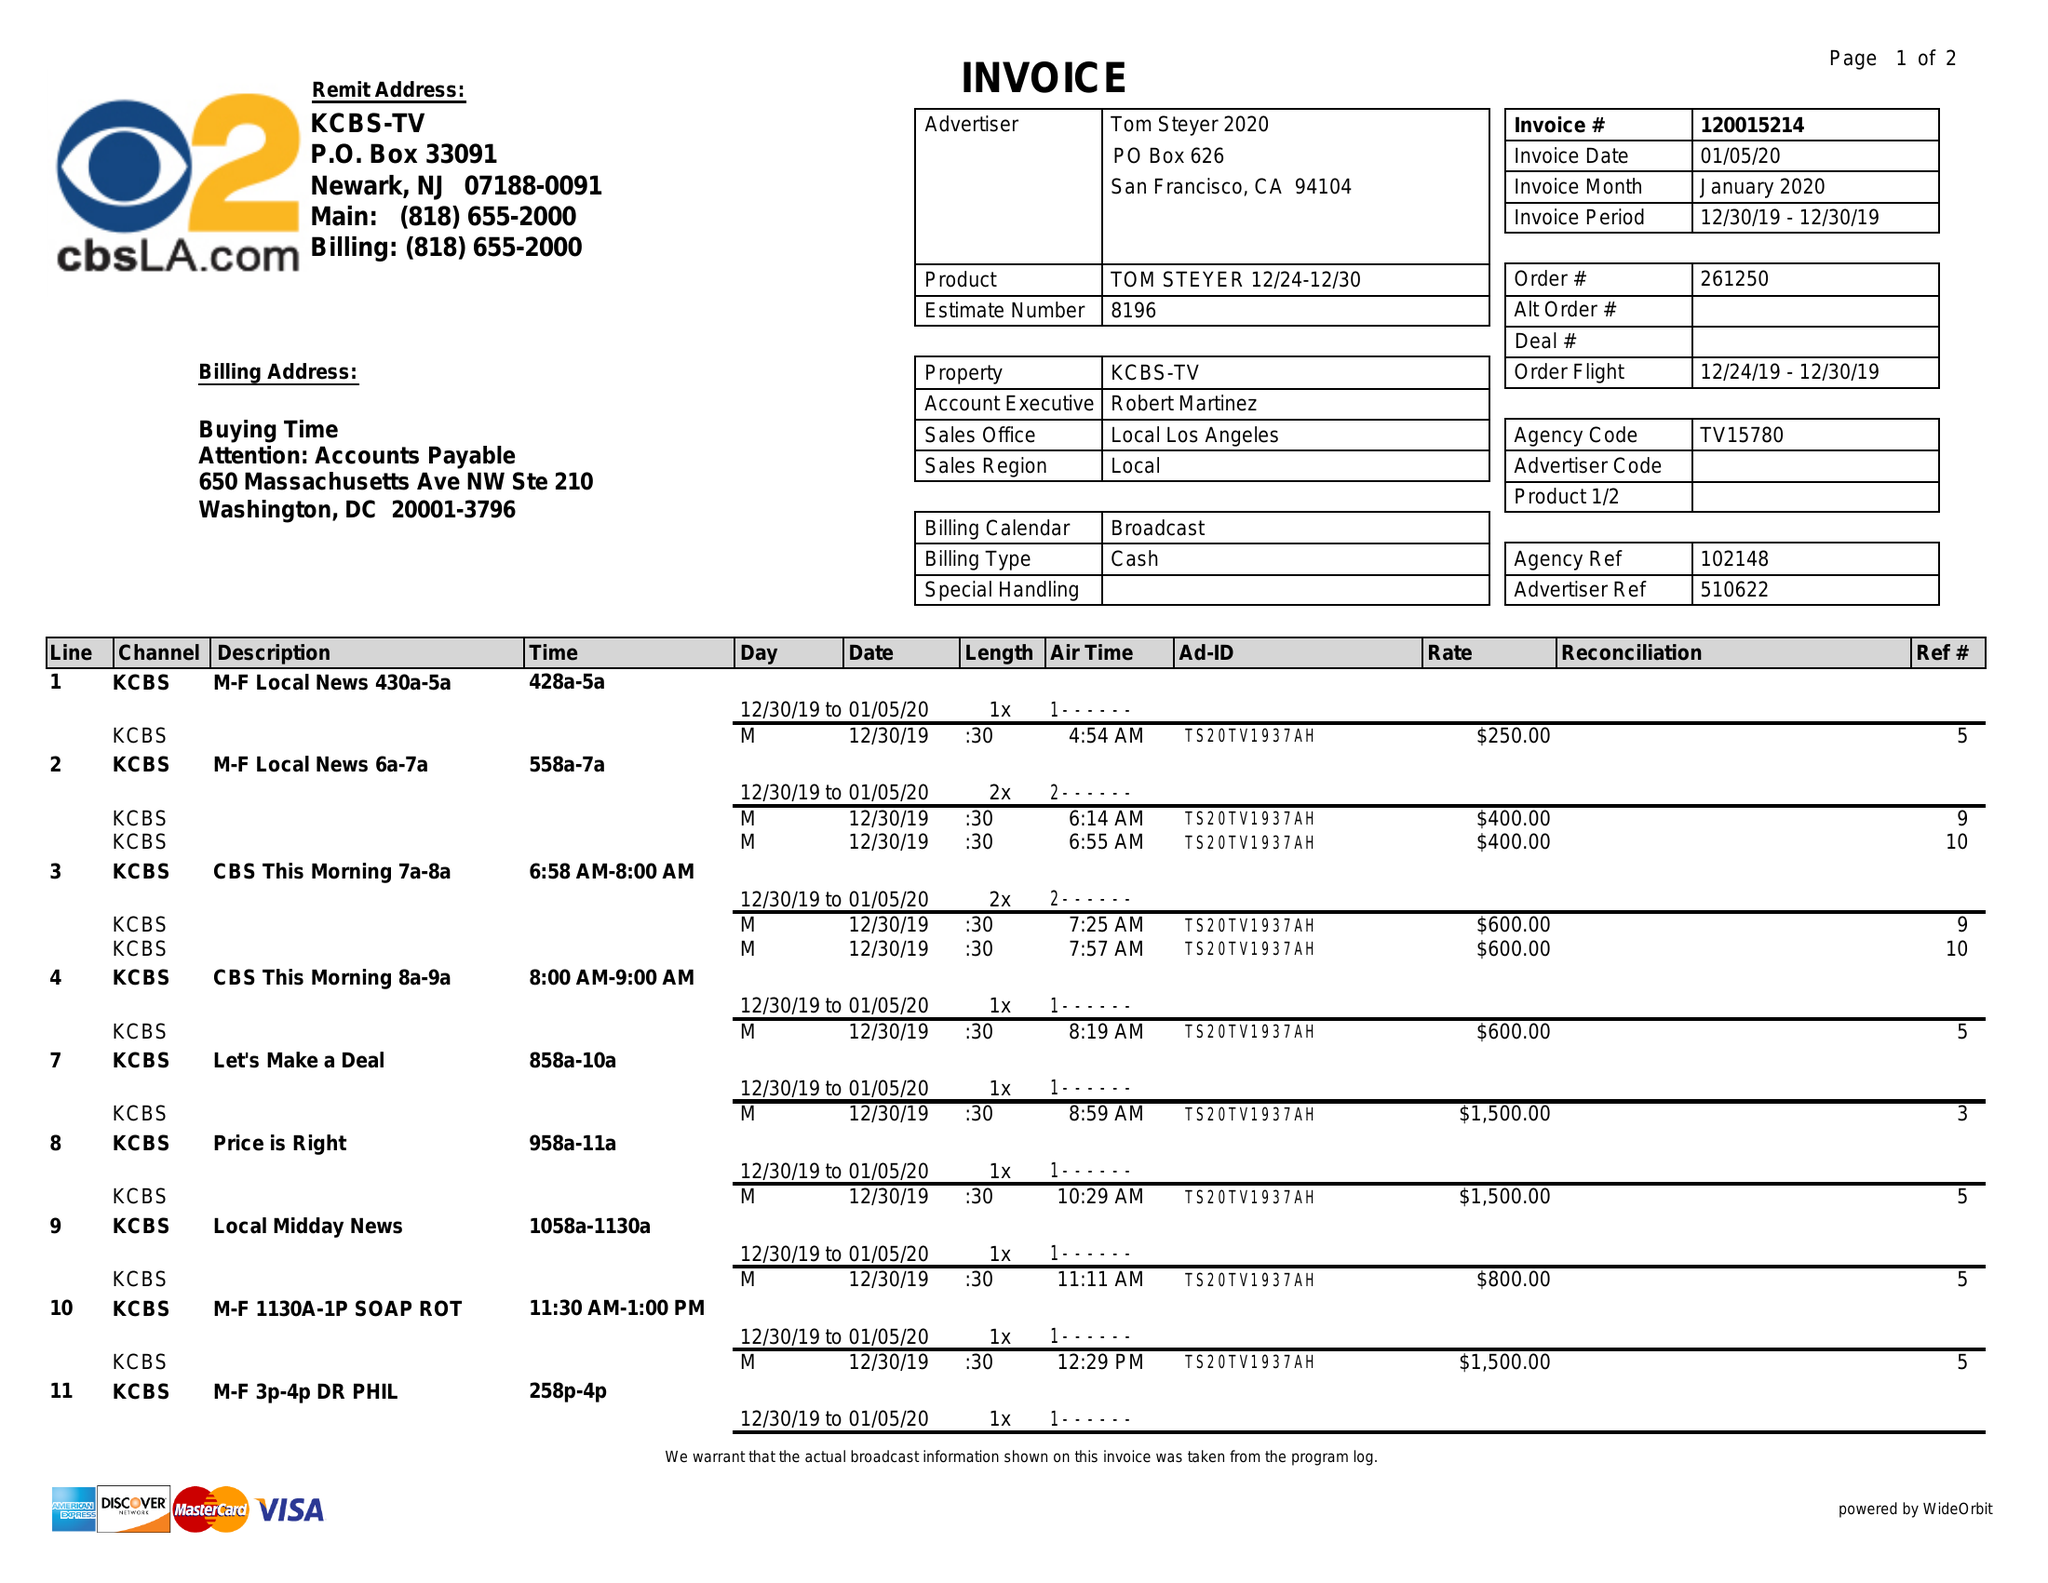What is the value for the contract_num?
Answer the question using a single word or phrase. 120015214 